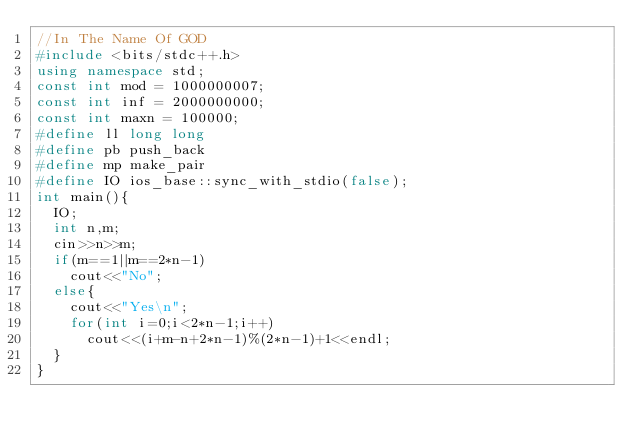<code> <loc_0><loc_0><loc_500><loc_500><_C++_>//In The Name Of GOD
#include <bits/stdc++.h>
using namespace std;
const int mod = 1000000007;
const int inf = 2000000000;
const int maxn = 100000;
#define ll long long
#define pb push_back
#define mp make_pair
#define IO ios_base::sync_with_stdio(false);
int main(){
  IO;
  int n,m;
  cin>>n>>m;
  if(m==1||m==2*n-1)
    cout<<"No";
  else{
    cout<<"Yes\n";
    for(int i=0;i<2*n-1;i++)
      cout<<(i+m-n+2*n-1)%(2*n-1)+1<<endl;
  }
}
</code> 